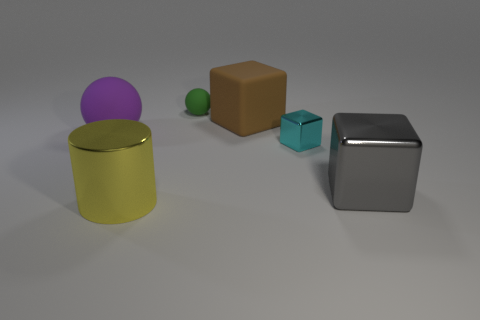Do the sphere that is behind the purple rubber object and the yellow object have the same size?
Give a very brief answer. No. Is the number of big objects behind the small green rubber ball less than the number of large yellow cylinders?
Your answer should be compact. Yes. What is the size of the matte object behind the large object behind the purple ball?
Your answer should be very brief. Small. Is there any other thing that is the same shape as the yellow thing?
Offer a very short reply. No. Are there fewer purple rubber things than yellow metallic spheres?
Ensure brevity in your answer.  No. There is a big object that is behind the gray cube and to the left of the large brown matte block; what is its material?
Provide a succinct answer. Rubber. Are there any large cubes behind the big sphere that is on the left side of the brown thing?
Your answer should be very brief. Yes. How many things are either cyan shiny cubes or big yellow rubber objects?
Your answer should be compact. 1. What is the shape of the object that is both in front of the tiny metallic cube and left of the rubber block?
Make the answer very short. Cylinder. Are the big thing that is behind the purple ball and the large yellow thing made of the same material?
Your response must be concise. No. 